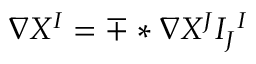<formula> <loc_0><loc_0><loc_500><loc_500>\nabla X ^ { I } = \mp * \nabla X ^ { J } I _ { J ^ { I }</formula> 